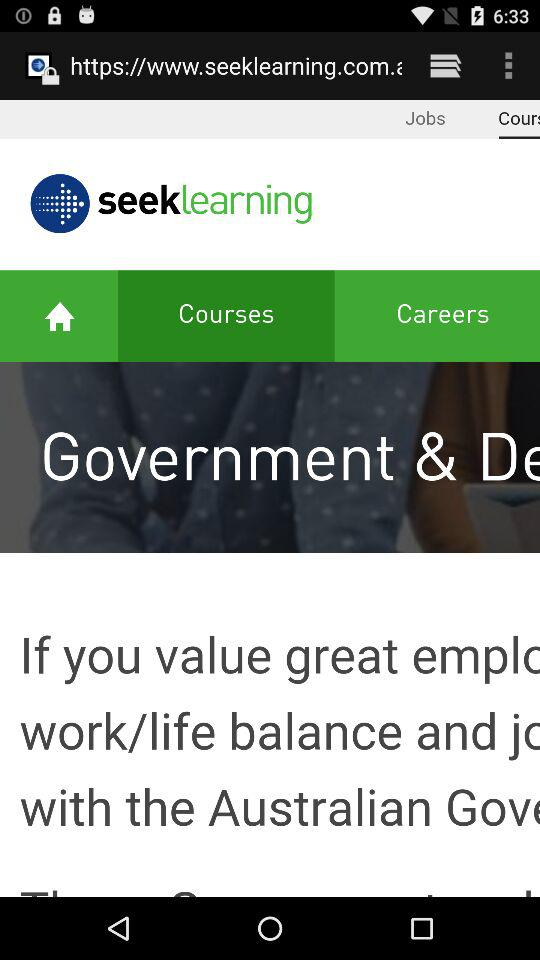Which tab is selected? The selected tab is "Courses". 